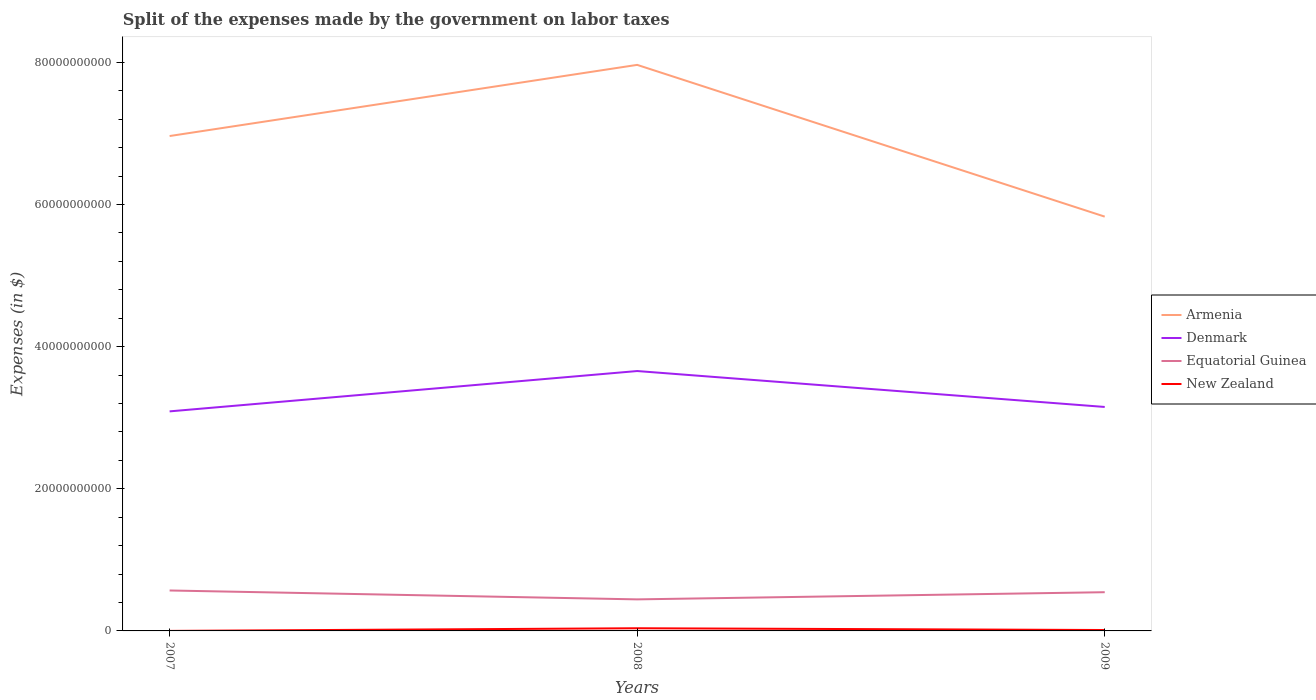How many different coloured lines are there?
Your answer should be compact. 4. Does the line corresponding to New Zealand intersect with the line corresponding to Armenia?
Keep it short and to the point. No. Is the number of lines equal to the number of legend labels?
Your response must be concise. Yes. Across all years, what is the maximum expenses made by the government on labor taxes in Equatorial Guinea?
Give a very brief answer. 4.44e+09. In which year was the expenses made by the government on labor taxes in Denmark maximum?
Give a very brief answer. 2007. What is the total expenses made by the government on labor taxes in Armenia in the graph?
Offer a very short reply. 1.13e+1. What is the difference between the highest and the second highest expenses made by the government on labor taxes in New Zealand?
Your answer should be compact. 3.73e+08. What is the difference between the highest and the lowest expenses made by the government on labor taxes in Armenia?
Give a very brief answer. 2. Is the expenses made by the government on labor taxes in Equatorial Guinea strictly greater than the expenses made by the government on labor taxes in New Zealand over the years?
Ensure brevity in your answer.  No. How many years are there in the graph?
Offer a terse response. 3. What is the difference between two consecutive major ticks on the Y-axis?
Offer a very short reply. 2.00e+1. Where does the legend appear in the graph?
Ensure brevity in your answer.  Center right. How are the legend labels stacked?
Ensure brevity in your answer.  Vertical. What is the title of the graph?
Your response must be concise. Split of the expenses made by the government on labor taxes. What is the label or title of the X-axis?
Provide a succinct answer. Years. What is the label or title of the Y-axis?
Offer a terse response. Expenses (in $). What is the Expenses (in $) of Armenia in 2007?
Keep it short and to the point. 6.96e+1. What is the Expenses (in $) in Denmark in 2007?
Give a very brief answer. 3.09e+1. What is the Expenses (in $) of Equatorial Guinea in 2007?
Ensure brevity in your answer.  5.69e+09. What is the Expenses (in $) of Armenia in 2008?
Offer a terse response. 7.97e+1. What is the Expenses (in $) in Denmark in 2008?
Ensure brevity in your answer.  3.66e+1. What is the Expenses (in $) of Equatorial Guinea in 2008?
Ensure brevity in your answer.  4.44e+09. What is the Expenses (in $) of New Zealand in 2008?
Provide a succinct answer. 3.75e+08. What is the Expenses (in $) of Armenia in 2009?
Offer a terse response. 5.83e+1. What is the Expenses (in $) of Denmark in 2009?
Keep it short and to the point. 3.15e+1. What is the Expenses (in $) in Equatorial Guinea in 2009?
Your response must be concise. 5.45e+09. What is the Expenses (in $) in New Zealand in 2009?
Offer a terse response. 1.28e+08. Across all years, what is the maximum Expenses (in $) in Armenia?
Make the answer very short. 7.97e+1. Across all years, what is the maximum Expenses (in $) in Denmark?
Make the answer very short. 3.66e+1. Across all years, what is the maximum Expenses (in $) in Equatorial Guinea?
Offer a very short reply. 5.69e+09. Across all years, what is the maximum Expenses (in $) in New Zealand?
Your response must be concise. 3.75e+08. Across all years, what is the minimum Expenses (in $) of Armenia?
Keep it short and to the point. 5.83e+1. Across all years, what is the minimum Expenses (in $) of Denmark?
Offer a terse response. 3.09e+1. Across all years, what is the minimum Expenses (in $) in Equatorial Guinea?
Give a very brief answer. 4.44e+09. Across all years, what is the minimum Expenses (in $) of New Zealand?
Ensure brevity in your answer.  2.00e+06. What is the total Expenses (in $) of Armenia in the graph?
Offer a very short reply. 2.08e+11. What is the total Expenses (in $) in Denmark in the graph?
Your response must be concise. 9.90e+1. What is the total Expenses (in $) of Equatorial Guinea in the graph?
Ensure brevity in your answer.  1.56e+1. What is the total Expenses (in $) of New Zealand in the graph?
Keep it short and to the point. 5.05e+08. What is the difference between the Expenses (in $) of Armenia in 2007 and that in 2008?
Your response must be concise. -1.00e+1. What is the difference between the Expenses (in $) of Denmark in 2007 and that in 2008?
Your answer should be very brief. -5.68e+09. What is the difference between the Expenses (in $) in Equatorial Guinea in 2007 and that in 2008?
Offer a terse response. 1.25e+09. What is the difference between the Expenses (in $) of New Zealand in 2007 and that in 2008?
Offer a very short reply. -3.73e+08. What is the difference between the Expenses (in $) in Armenia in 2007 and that in 2009?
Make the answer very short. 1.13e+1. What is the difference between the Expenses (in $) of Denmark in 2007 and that in 2009?
Offer a terse response. -6.21e+08. What is the difference between the Expenses (in $) in Equatorial Guinea in 2007 and that in 2009?
Your response must be concise. 2.42e+08. What is the difference between the Expenses (in $) in New Zealand in 2007 and that in 2009?
Offer a terse response. -1.26e+08. What is the difference between the Expenses (in $) of Armenia in 2008 and that in 2009?
Your response must be concise. 2.14e+1. What is the difference between the Expenses (in $) in Denmark in 2008 and that in 2009?
Keep it short and to the point. 5.06e+09. What is the difference between the Expenses (in $) of Equatorial Guinea in 2008 and that in 2009?
Provide a short and direct response. -1.01e+09. What is the difference between the Expenses (in $) in New Zealand in 2008 and that in 2009?
Offer a very short reply. 2.47e+08. What is the difference between the Expenses (in $) in Armenia in 2007 and the Expenses (in $) in Denmark in 2008?
Provide a succinct answer. 3.31e+1. What is the difference between the Expenses (in $) of Armenia in 2007 and the Expenses (in $) of Equatorial Guinea in 2008?
Provide a short and direct response. 6.52e+1. What is the difference between the Expenses (in $) in Armenia in 2007 and the Expenses (in $) in New Zealand in 2008?
Give a very brief answer. 6.93e+1. What is the difference between the Expenses (in $) in Denmark in 2007 and the Expenses (in $) in Equatorial Guinea in 2008?
Your answer should be very brief. 2.65e+1. What is the difference between the Expenses (in $) in Denmark in 2007 and the Expenses (in $) in New Zealand in 2008?
Your response must be concise. 3.05e+1. What is the difference between the Expenses (in $) of Equatorial Guinea in 2007 and the Expenses (in $) of New Zealand in 2008?
Provide a succinct answer. 5.32e+09. What is the difference between the Expenses (in $) in Armenia in 2007 and the Expenses (in $) in Denmark in 2009?
Provide a succinct answer. 3.81e+1. What is the difference between the Expenses (in $) of Armenia in 2007 and the Expenses (in $) of Equatorial Guinea in 2009?
Make the answer very short. 6.42e+1. What is the difference between the Expenses (in $) of Armenia in 2007 and the Expenses (in $) of New Zealand in 2009?
Provide a short and direct response. 6.95e+1. What is the difference between the Expenses (in $) in Denmark in 2007 and the Expenses (in $) in Equatorial Guinea in 2009?
Provide a succinct answer. 2.54e+1. What is the difference between the Expenses (in $) in Denmark in 2007 and the Expenses (in $) in New Zealand in 2009?
Give a very brief answer. 3.08e+1. What is the difference between the Expenses (in $) of Equatorial Guinea in 2007 and the Expenses (in $) of New Zealand in 2009?
Your response must be concise. 5.56e+09. What is the difference between the Expenses (in $) in Armenia in 2008 and the Expenses (in $) in Denmark in 2009?
Offer a terse response. 4.81e+1. What is the difference between the Expenses (in $) of Armenia in 2008 and the Expenses (in $) of Equatorial Guinea in 2009?
Your answer should be compact. 7.42e+1. What is the difference between the Expenses (in $) of Armenia in 2008 and the Expenses (in $) of New Zealand in 2009?
Offer a terse response. 7.95e+1. What is the difference between the Expenses (in $) in Denmark in 2008 and the Expenses (in $) in Equatorial Guinea in 2009?
Provide a succinct answer. 3.11e+1. What is the difference between the Expenses (in $) of Denmark in 2008 and the Expenses (in $) of New Zealand in 2009?
Your response must be concise. 3.64e+1. What is the difference between the Expenses (in $) in Equatorial Guinea in 2008 and the Expenses (in $) in New Zealand in 2009?
Offer a very short reply. 4.31e+09. What is the average Expenses (in $) of Armenia per year?
Keep it short and to the point. 6.92e+1. What is the average Expenses (in $) of Denmark per year?
Ensure brevity in your answer.  3.30e+1. What is the average Expenses (in $) in Equatorial Guinea per year?
Provide a short and direct response. 5.19e+09. What is the average Expenses (in $) of New Zealand per year?
Offer a very short reply. 1.68e+08. In the year 2007, what is the difference between the Expenses (in $) of Armenia and Expenses (in $) of Denmark?
Your answer should be compact. 3.87e+1. In the year 2007, what is the difference between the Expenses (in $) in Armenia and Expenses (in $) in Equatorial Guinea?
Your answer should be very brief. 6.39e+1. In the year 2007, what is the difference between the Expenses (in $) of Armenia and Expenses (in $) of New Zealand?
Your response must be concise. 6.96e+1. In the year 2007, what is the difference between the Expenses (in $) of Denmark and Expenses (in $) of Equatorial Guinea?
Your answer should be compact. 2.52e+1. In the year 2007, what is the difference between the Expenses (in $) of Denmark and Expenses (in $) of New Zealand?
Offer a terse response. 3.09e+1. In the year 2007, what is the difference between the Expenses (in $) of Equatorial Guinea and Expenses (in $) of New Zealand?
Give a very brief answer. 5.69e+09. In the year 2008, what is the difference between the Expenses (in $) in Armenia and Expenses (in $) in Denmark?
Your answer should be compact. 4.31e+1. In the year 2008, what is the difference between the Expenses (in $) in Armenia and Expenses (in $) in Equatorial Guinea?
Your answer should be compact. 7.52e+1. In the year 2008, what is the difference between the Expenses (in $) in Armenia and Expenses (in $) in New Zealand?
Make the answer very short. 7.93e+1. In the year 2008, what is the difference between the Expenses (in $) in Denmark and Expenses (in $) in Equatorial Guinea?
Give a very brief answer. 3.21e+1. In the year 2008, what is the difference between the Expenses (in $) in Denmark and Expenses (in $) in New Zealand?
Provide a succinct answer. 3.62e+1. In the year 2008, what is the difference between the Expenses (in $) of Equatorial Guinea and Expenses (in $) of New Zealand?
Your answer should be compact. 4.06e+09. In the year 2009, what is the difference between the Expenses (in $) in Armenia and Expenses (in $) in Denmark?
Provide a short and direct response. 2.68e+1. In the year 2009, what is the difference between the Expenses (in $) of Armenia and Expenses (in $) of Equatorial Guinea?
Provide a succinct answer. 5.28e+1. In the year 2009, what is the difference between the Expenses (in $) in Armenia and Expenses (in $) in New Zealand?
Your answer should be very brief. 5.82e+1. In the year 2009, what is the difference between the Expenses (in $) of Denmark and Expenses (in $) of Equatorial Guinea?
Provide a succinct answer. 2.61e+1. In the year 2009, what is the difference between the Expenses (in $) in Denmark and Expenses (in $) in New Zealand?
Provide a short and direct response. 3.14e+1. In the year 2009, what is the difference between the Expenses (in $) in Equatorial Guinea and Expenses (in $) in New Zealand?
Provide a succinct answer. 5.32e+09. What is the ratio of the Expenses (in $) of Armenia in 2007 to that in 2008?
Keep it short and to the point. 0.87. What is the ratio of the Expenses (in $) in Denmark in 2007 to that in 2008?
Ensure brevity in your answer.  0.84. What is the ratio of the Expenses (in $) of Equatorial Guinea in 2007 to that in 2008?
Provide a short and direct response. 1.28. What is the ratio of the Expenses (in $) of New Zealand in 2007 to that in 2008?
Your response must be concise. 0.01. What is the ratio of the Expenses (in $) in Armenia in 2007 to that in 2009?
Your answer should be compact. 1.19. What is the ratio of the Expenses (in $) of Denmark in 2007 to that in 2009?
Your answer should be compact. 0.98. What is the ratio of the Expenses (in $) of Equatorial Guinea in 2007 to that in 2009?
Keep it short and to the point. 1.04. What is the ratio of the Expenses (in $) of New Zealand in 2007 to that in 2009?
Keep it short and to the point. 0.02. What is the ratio of the Expenses (in $) in Armenia in 2008 to that in 2009?
Make the answer very short. 1.37. What is the ratio of the Expenses (in $) in Denmark in 2008 to that in 2009?
Give a very brief answer. 1.16. What is the ratio of the Expenses (in $) in Equatorial Guinea in 2008 to that in 2009?
Ensure brevity in your answer.  0.81. What is the ratio of the Expenses (in $) of New Zealand in 2008 to that in 2009?
Your response must be concise. 2.93. What is the difference between the highest and the second highest Expenses (in $) in Armenia?
Provide a short and direct response. 1.00e+1. What is the difference between the highest and the second highest Expenses (in $) in Denmark?
Provide a succinct answer. 5.06e+09. What is the difference between the highest and the second highest Expenses (in $) in Equatorial Guinea?
Your answer should be very brief. 2.42e+08. What is the difference between the highest and the second highest Expenses (in $) in New Zealand?
Provide a succinct answer. 2.47e+08. What is the difference between the highest and the lowest Expenses (in $) of Armenia?
Ensure brevity in your answer.  2.14e+1. What is the difference between the highest and the lowest Expenses (in $) in Denmark?
Your response must be concise. 5.68e+09. What is the difference between the highest and the lowest Expenses (in $) in Equatorial Guinea?
Offer a terse response. 1.25e+09. What is the difference between the highest and the lowest Expenses (in $) of New Zealand?
Keep it short and to the point. 3.73e+08. 